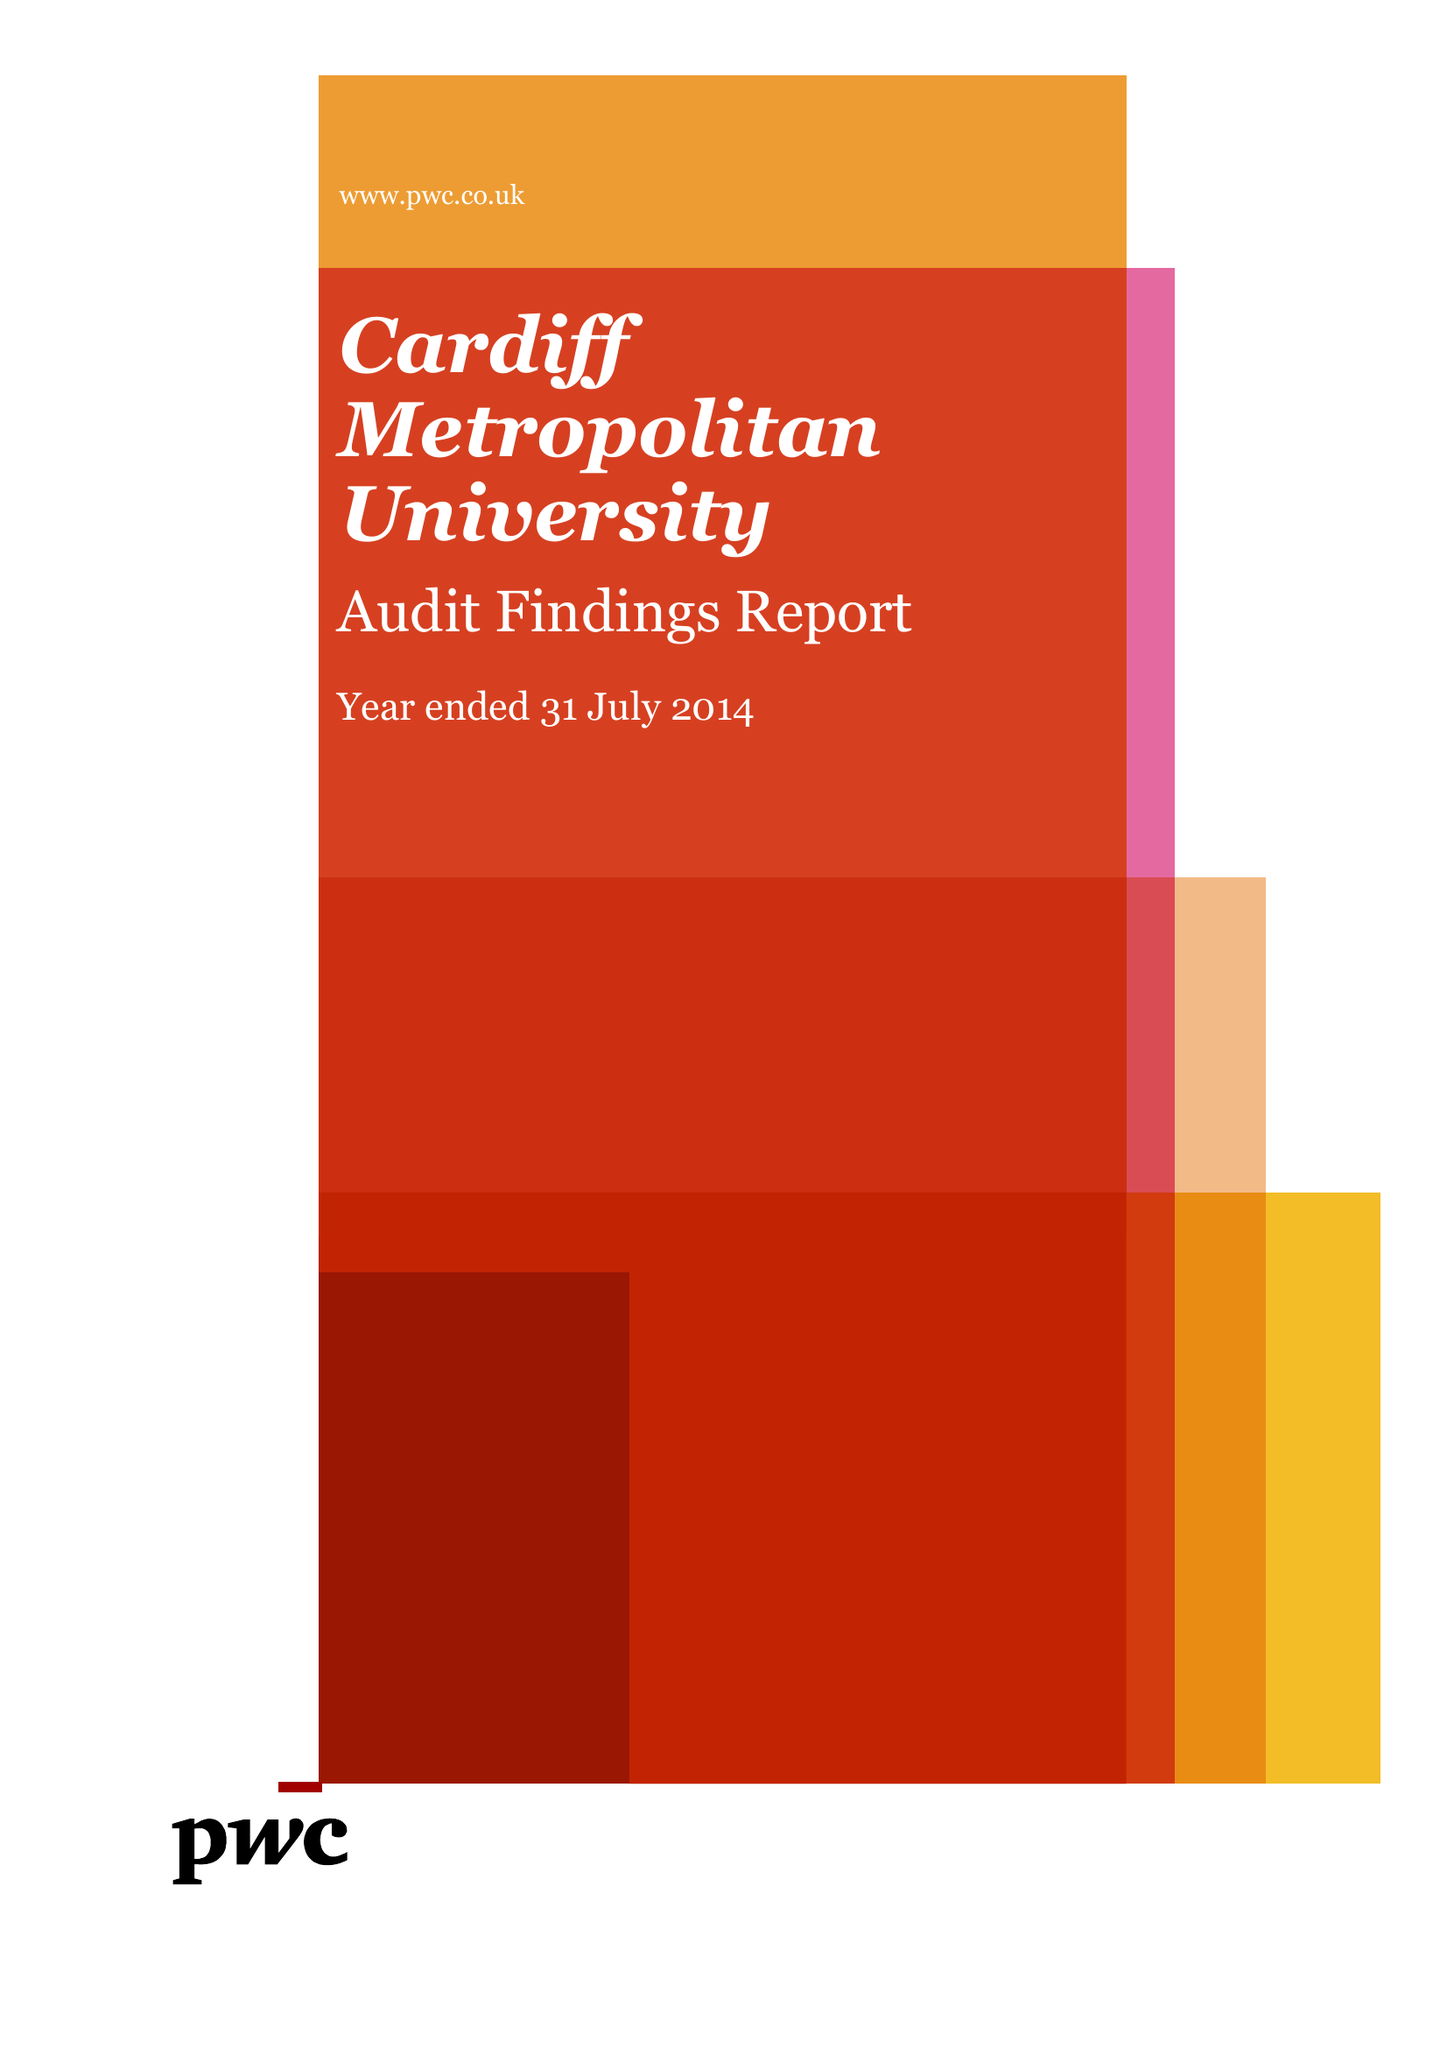What is the value for the address__street_line?
Answer the question using a single word or phrase. WESTERN AVENUE 